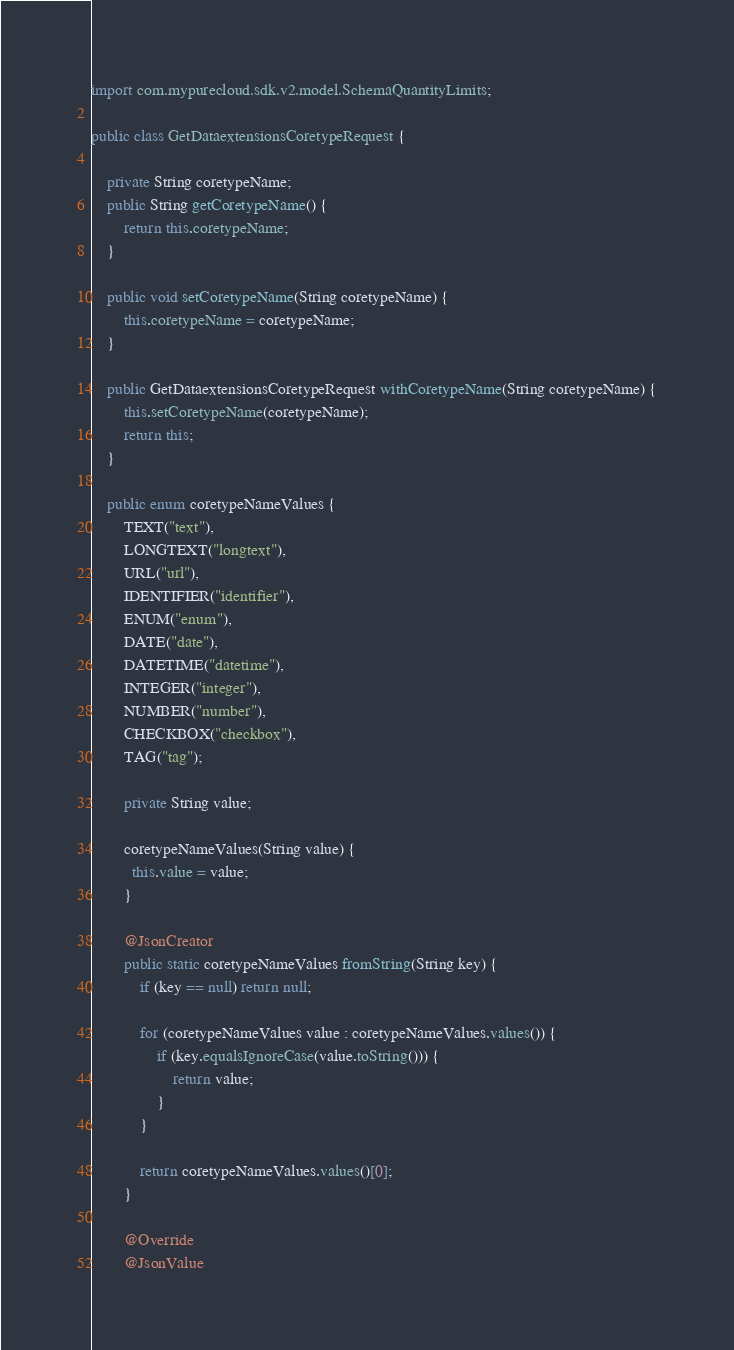Convert code to text. <code><loc_0><loc_0><loc_500><loc_500><_Java_>import com.mypurecloud.sdk.v2.model.SchemaQuantityLimits;

public class GetDataextensionsCoretypeRequest {
    
	private String coretypeName;
	public String getCoretypeName() {
		return this.coretypeName;
	}

	public void setCoretypeName(String coretypeName) {
		this.coretypeName = coretypeName;
	}

	public GetDataextensionsCoretypeRequest withCoretypeName(String coretypeName) {
	    this.setCoretypeName(coretypeName);
	    return this;
	} 

	public enum coretypeNameValues { 
		TEXT("text"), 
		LONGTEXT("longtext"), 
		URL("url"), 
		IDENTIFIER("identifier"), 
		ENUM("enum"), 
		DATE("date"), 
		DATETIME("datetime"), 
		INTEGER("integer"), 
		NUMBER("number"), 
		CHECKBOX("checkbox"), 
		TAG("tag");

		private String value;

		coretypeNameValues(String value) {
		  this.value = value;
		}

		@JsonCreator
		public static coretypeNameValues fromString(String key) {
			if (key == null) return null;

			for (coretypeNameValues value : coretypeNameValues.values()) {
				if (key.equalsIgnoreCase(value.toString())) {
					return value;
				}
			}

			return coretypeNameValues.values()[0];
		}

		@Override
		@JsonValue</code> 